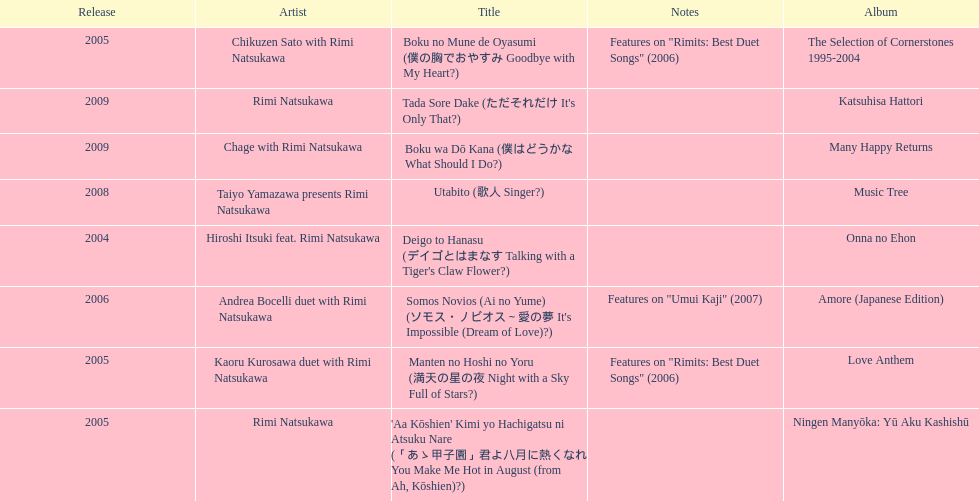During which year was the highest number of titles released? 2005. Could you parse the entire table? {'header': ['Release', 'Artist', 'Title', 'Notes', 'Album'], 'rows': [['2005', 'Chikuzen Sato with Rimi Natsukawa', 'Boku no Mune de Oyasumi (僕の胸でおやすみ Goodbye with My Heart?)', 'Features on "Rimits: Best Duet Songs" (2006)', 'The Selection of Cornerstones 1995-2004'], ['2009', 'Rimi Natsukawa', "Tada Sore Dake (ただそれだけ It's Only That?)", '', 'Katsuhisa Hattori'], ['2009', 'Chage with Rimi Natsukawa', 'Boku wa Dō Kana (僕はどうかな What Should I Do?)', '', 'Many Happy Returns'], ['2008', 'Taiyo Yamazawa presents Rimi Natsukawa', 'Utabito (歌人 Singer?)', '', 'Music Tree'], ['2004', 'Hiroshi Itsuki feat. Rimi Natsukawa', "Deigo to Hanasu (デイゴとはまなす Talking with a Tiger's Claw Flower?)", '', 'Onna no Ehon'], ['2006', 'Andrea Bocelli duet with Rimi Natsukawa', "Somos Novios (Ai no Yume) (ソモス・ノビオス～愛の夢 It's Impossible (Dream of Love)?)", 'Features on "Umui Kaji" (2007)', 'Amore (Japanese Edition)'], ['2005', 'Kaoru Kurosawa duet with Rimi Natsukawa', 'Manten no Hoshi no Yoru (満天の星の夜 Night with a Sky Full of Stars?)', 'Features on "Rimits: Best Duet Songs" (2006)', 'Love Anthem'], ['2005', 'Rimi Natsukawa', "'Aa Kōshien' Kimi yo Hachigatsu ni Atsuku Nare (「あゝ甲子園」君よ八月に熱くなれ You Make Me Hot in August (from Ah, Kōshien)?)", '', 'Ningen Manyōka: Yū Aku Kashishū']]} 